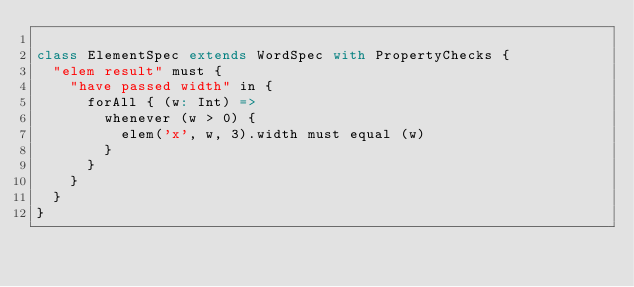<code> <loc_0><loc_0><loc_500><loc_500><_Scala_>
class ElementSpec extends WordSpec with PropertyChecks {
  "elem result" must {
    "have passed width" in {
      forAll { (w: Int) =>
        whenever (w > 0) {
          elem('x', w, 3).width must equal (w)
        }
      }
    }
  }
}
</code> 